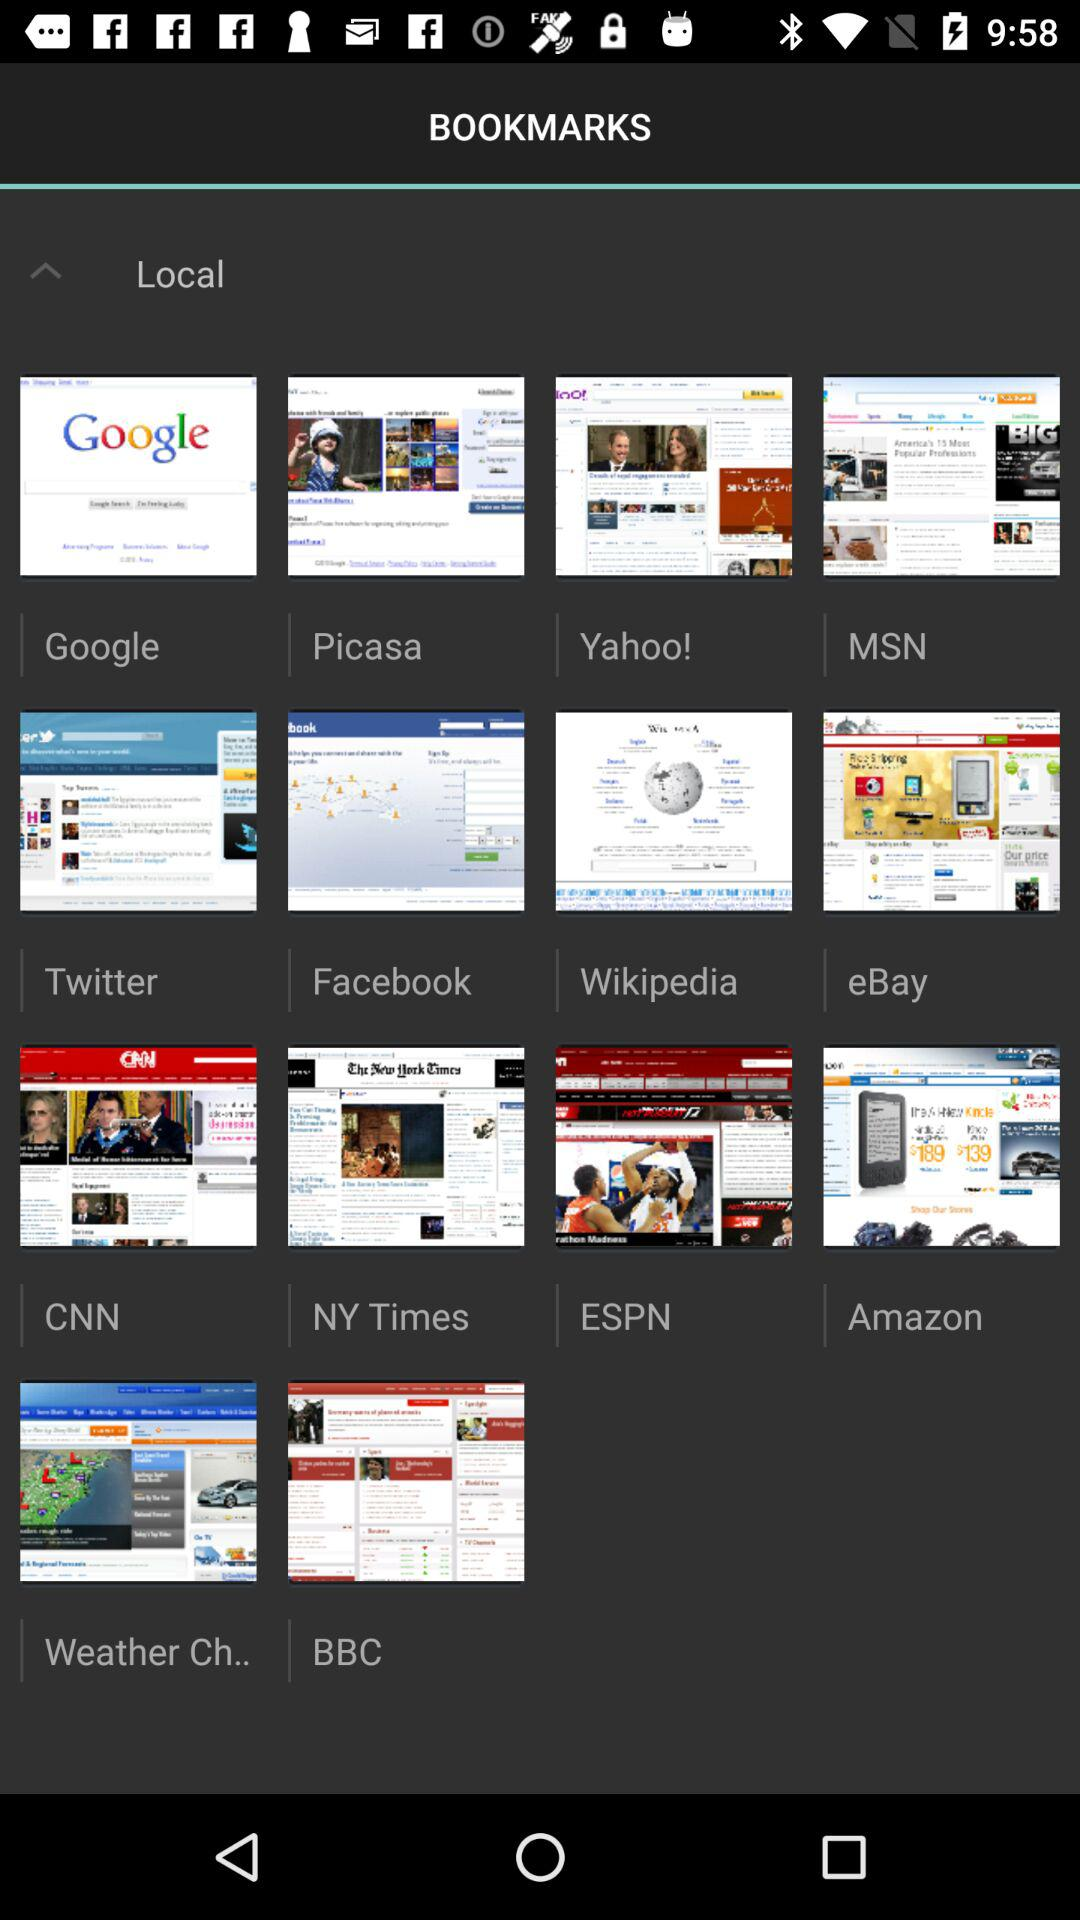What websites do I have saved in my bookmarks? The websites saved in my bookmarks are "Google", "Picasa", "Yahoo!", "MSN", "Twitter", "Facebook", "Wikipedia", "eBay", "CNN", "NY Times", "ESPN", "Amazon", "Weather Ch.." and "BBC". 